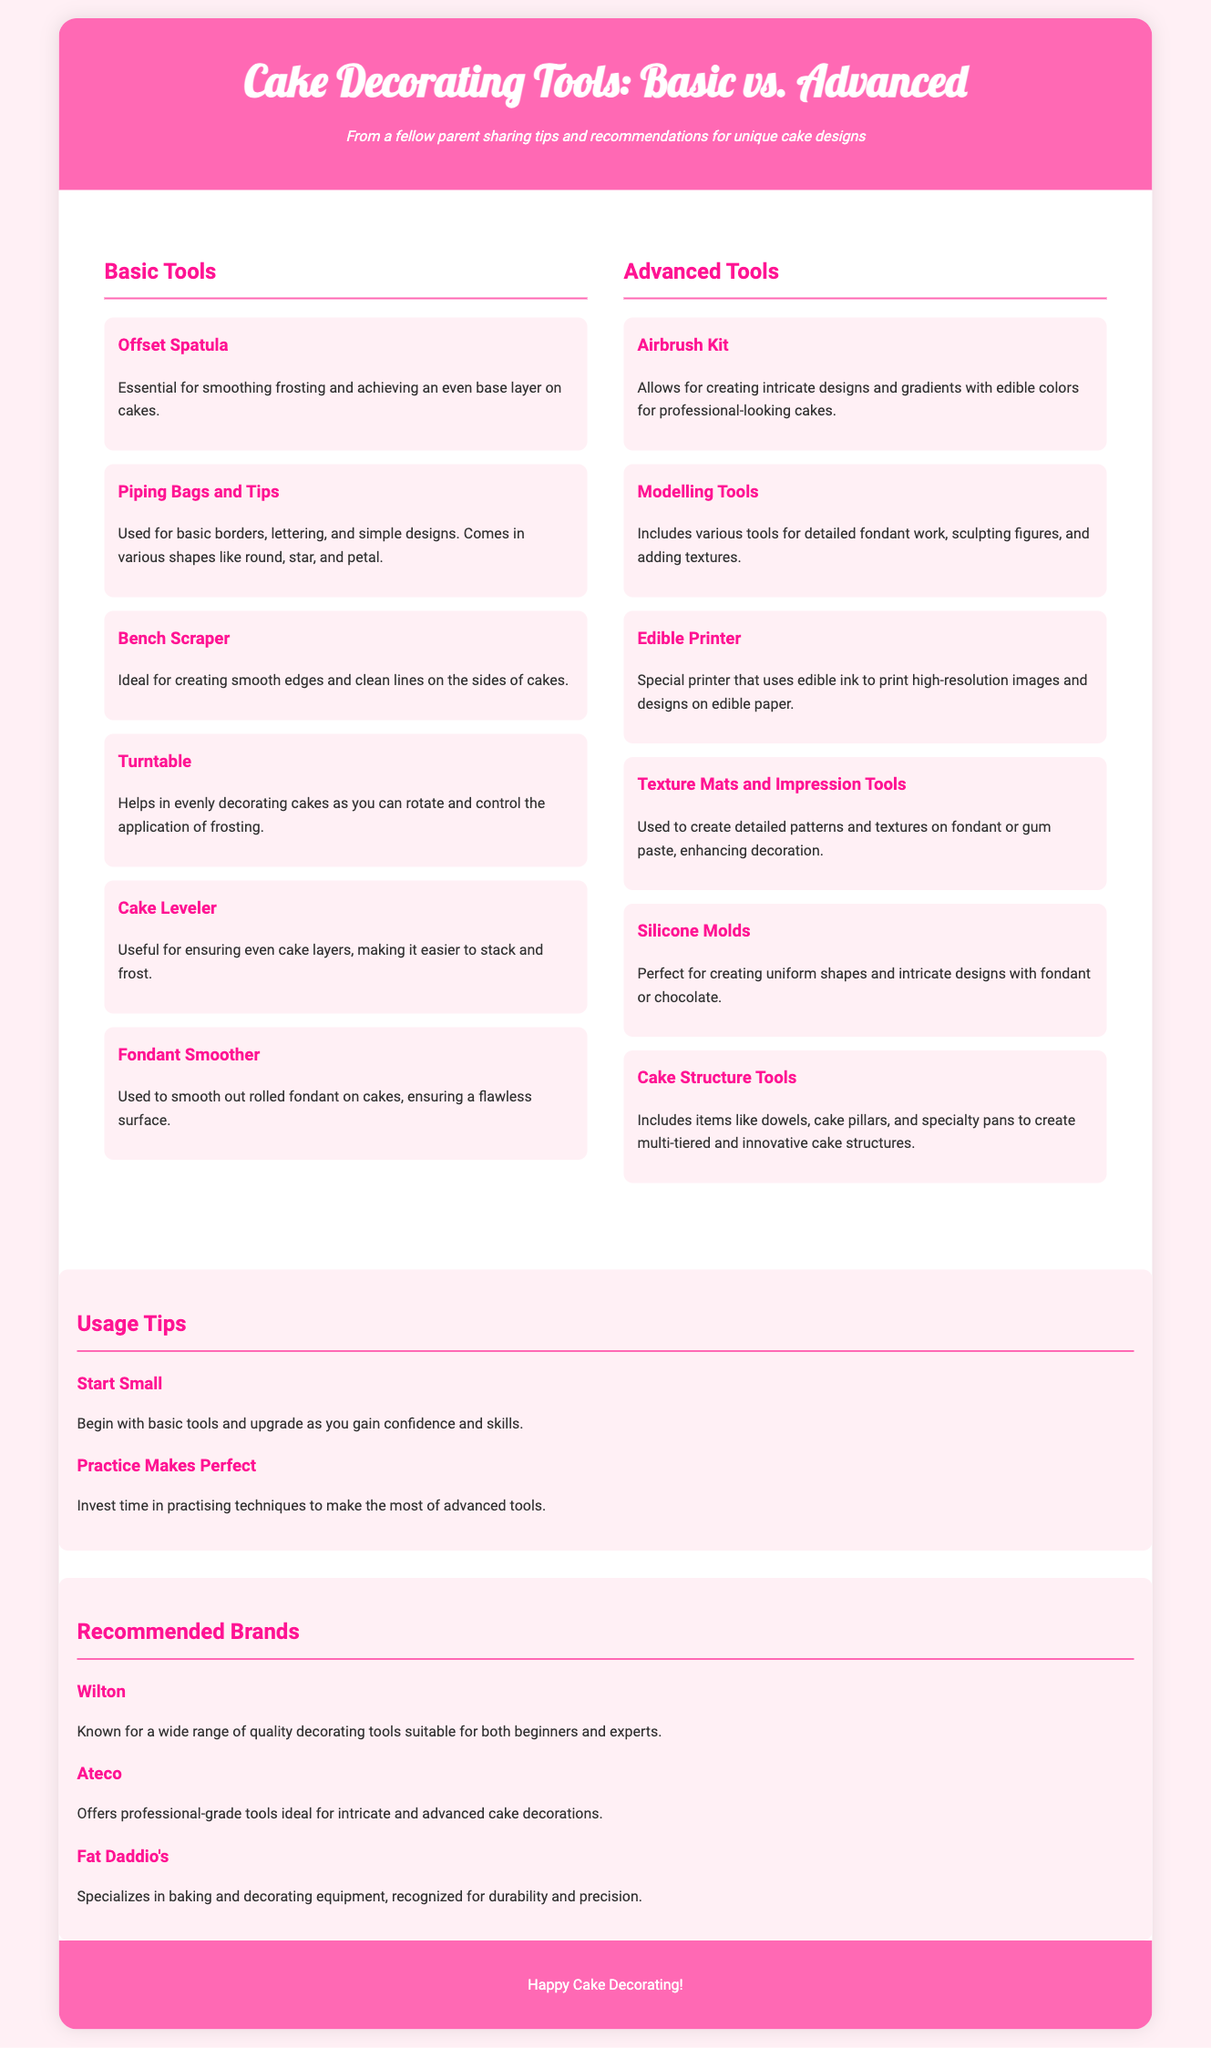What is the first tool listed under Basic Tools? The first tool listed is the Offset Spatula, which is essential for smoothing frosting and achieving an even base layer on cakes.
Answer: Offset Spatula How many tools are listed under Advanced Tools? There are six tools listed under Advanced Tools in the document.
Answer: Six What is an Airbrush Kit used for? The Airbrush Kit allows for creating intricate designs and gradients with edible colors for professional-looking cakes.
Answer: Intricate designs Which brand is known for quality decorating tools suitable for both beginners and experts? The document mentions Wilton as a brand known for a wide range of quality decorating tools suited for both beginners and experts.
Answer: Wilton What is a recommended tip for using cake decorating tools? The document recommends starting small with basic tools and upgrading as confidence and skills increase.
Answer: Start Small Which tool is described as ideal for creating smooth edges on cakes? The Bench Scraper is described as ideal for creating smooth edges and clean lines on the sides of cakes.
Answer: Bench Scraper What does the Edible Printer use to print images? The Edible Printer uses edible ink to print high-resolution images and designs on edible paper.
Answer: Edible ink What is the purpose of the Cake Leveler? The Cake Leveler is useful for ensuring even cake layers, making it easier to stack and frost.
Answer: Even cake layers 